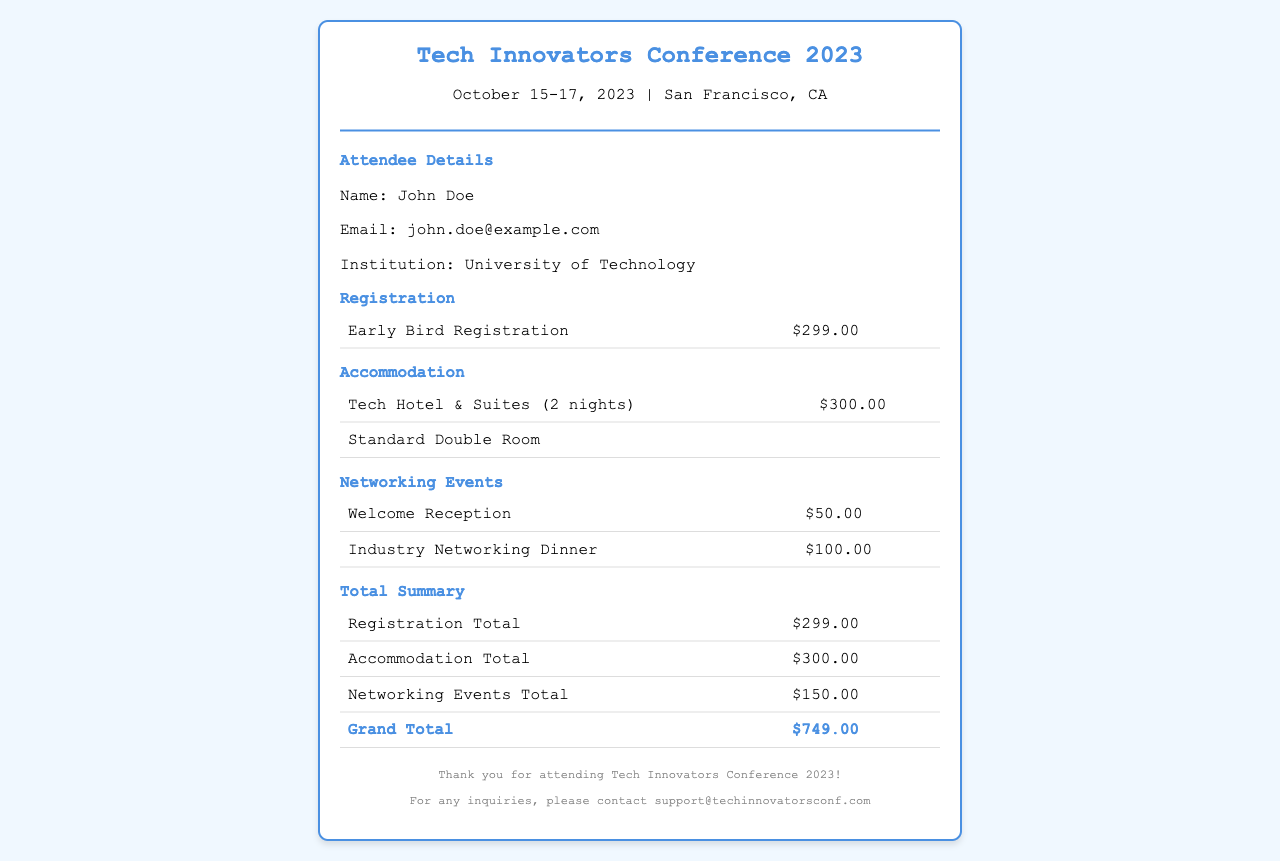What is the name of the conference? The name of the conference is in the header section of the document.
Answer: Tech Innovators Conference 2023 When did the conference take place? The conference dates are mentioned right under the title in the header.
Answer: October 15-17, 2023 What was the price for early bird registration? The registration information includes a specific price listed in the document.
Answer: $299.00 How much was spent on accommodation? The accommodation section specifies the total cost of the hotel stay.
Answer: $300.00 What are the titles of the networking events? The networking events section lists the different events included in the receipt.
Answer: Welcome Reception, Industry Networking Dinner What is the total amount spent on networking events? The total cost for networking events is provided in the summary table of the document.
Answer: $150.00 What is the grand total for all expenses? The grand total is calculated based on the summaries provided for registration, accommodation, and networking events.
Answer: $749.00 Who is the attendee's institution? The attendee's institution is specified in the attendee details section.
Answer: University of Technology What is the email of the attendee? The email address of the attendee is listed in the details section.
Answer: john.doe@example.com 